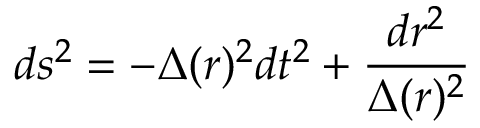<formula> <loc_0><loc_0><loc_500><loc_500>d s ^ { 2 } = - \Delta ( r ) ^ { 2 } d t ^ { 2 } + \frac { d r ^ { 2 } } { \Delta ( r ) ^ { 2 } }</formula> 